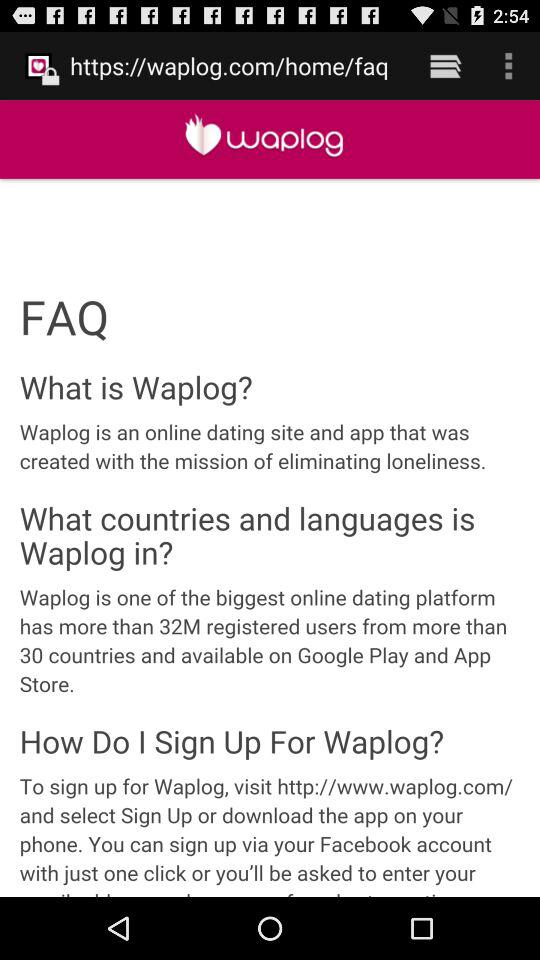What is the app name? The app name is "waplog". 